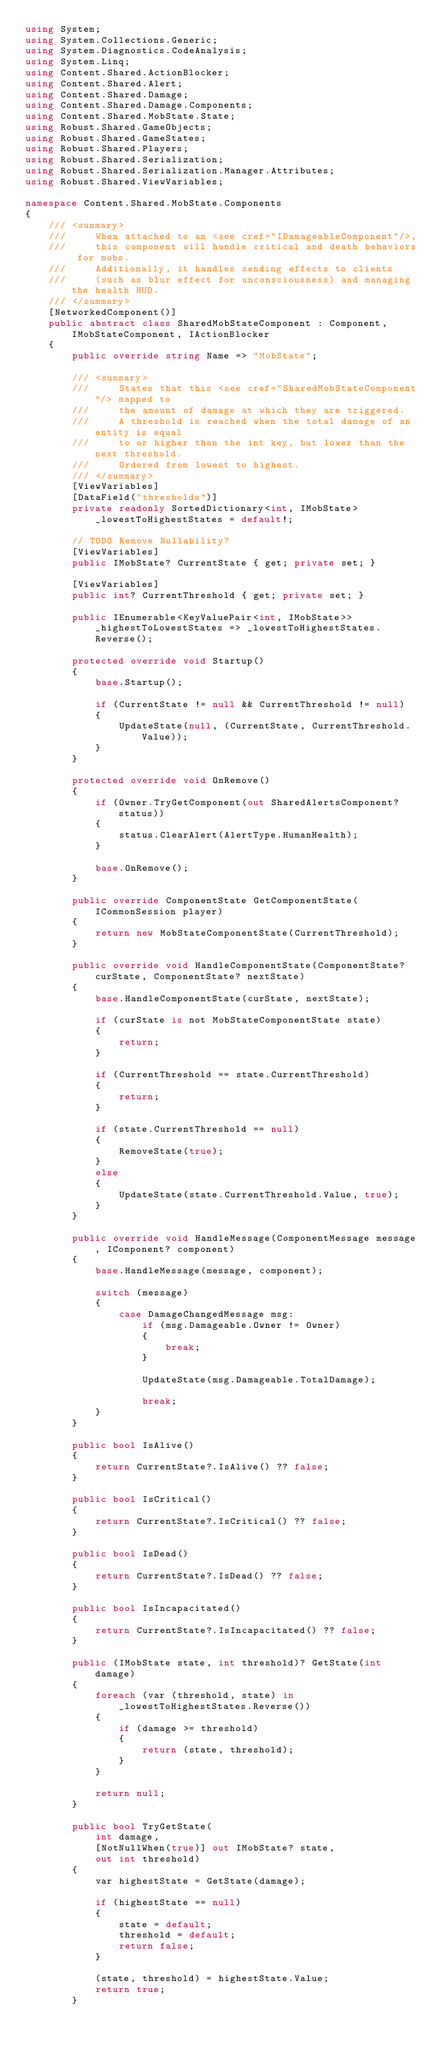Convert code to text. <code><loc_0><loc_0><loc_500><loc_500><_C#_>using System;
using System.Collections.Generic;
using System.Diagnostics.CodeAnalysis;
using System.Linq;
using Content.Shared.ActionBlocker;
using Content.Shared.Alert;
using Content.Shared.Damage;
using Content.Shared.Damage.Components;
using Content.Shared.MobState.State;
using Robust.Shared.GameObjects;
using Robust.Shared.GameStates;
using Robust.Shared.Players;
using Robust.Shared.Serialization;
using Robust.Shared.Serialization.Manager.Attributes;
using Robust.Shared.ViewVariables;

namespace Content.Shared.MobState.Components
{
    /// <summary>
    ///     When attached to an <see cref="IDamageableComponent"/>,
    ///     this component will handle critical and death behaviors for mobs.
    ///     Additionally, it handles sending effects to clients
    ///     (such as blur effect for unconsciousness) and managing the health HUD.
    /// </summary>
    [NetworkedComponent()]
    public abstract class SharedMobStateComponent : Component, IMobStateComponent, IActionBlocker
    {
        public override string Name => "MobState";

        /// <summary>
        ///     States that this <see cref="SharedMobStateComponent"/> mapped to
        ///     the amount of damage at which they are triggered.
        ///     A threshold is reached when the total damage of an entity is equal
        ///     to or higher than the int key, but lower than the next threshold.
        ///     Ordered from lowest to highest.
        /// </summary>
        [ViewVariables]
        [DataField("thresholds")]
        private readonly SortedDictionary<int, IMobState> _lowestToHighestStates = default!;

        // TODO Remove Nullability?
        [ViewVariables]
        public IMobState? CurrentState { get; private set; }

        [ViewVariables]
        public int? CurrentThreshold { get; private set; }

        public IEnumerable<KeyValuePair<int, IMobState>> _highestToLowestStates => _lowestToHighestStates.Reverse();

        protected override void Startup()
        {
            base.Startup();

            if (CurrentState != null && CurrentThreshold != null)
            {
                UpdateState(null, (CurrentState, CurrentThreshold.Value));
            }
        }

        protected override void OnRemove()
        {
            if (Owner.TryGetComponent(out SharedAlertsComponent? status))
            {
                status.ClearAlert(AlertType.HumanHealth);
            }

            base.OnRemove();
        }

        public override ComponentState GetComponentState(ICommonSession player)
        {
            return new MobStateComponentState(CurrentThreshold);
        }

        public override void HandleComponentState(ComponentState? curState, ComponentState? nextState)
        {
            base.HandleComponentState(curState, nextState);

            if (curState is not MobStateComponentState state)
            {
                return;
            }

            if (CurrentThreshold == state.CurrentThreshold)
            {
                return;
            }

            if (state.CurrentThreshold == null)
            {
                RemoveState(true);
            }
            else
            {
                UpdateState(state.CurrentThreshold.Value, true);
            }
        }

        public override void HandleMessage(ComponentMessage message, IComponent? component)
        {
            base.HandleMessage(message, component);

            switch (message)
            {
                case DamageChangedMessage msg:
                    if (msg.Damageable.Owner != Owner)
                    {
                        break;
                    }

                    UpdateState(msg.Damageable.TotalDamage);

                    break;
            }
        }

        public bool IsAlive()
        {
            return CurrentState?.IsAlive() ?? false;
        }

        public bool IsCritical()
        {
            return CurrentState?.IsCritical() ?? false;
        }

        public bool IsDead()
        {
            return CurrentState?.IsDead() ?? false;
        }

        public bool IsIncapacitated()
        {
            return CurrentState?.IsIncapacitated() ?? false;
        }

        public (IMobState state, int threshold)? GetState(int damage)
        {
            foreach (var (threshold, state) in _lowestToHighestStates.Reverse())
            {
                if (damage >= threshold)
                {
                    return (state, threshold);
                }
            }

            return null;
        }

        public bool TryGetState(
            int damage,
            [NotNullWhen(true)] out IMobState? state,
            out int threshold)
        {
            var highestState = GetState(damage);

            if (highestState == null)
            {
                state = default;
                threshold = default;
                return false;
            }

            (state, threshold) = highestState.Value;
            return true;
        }
</code> 